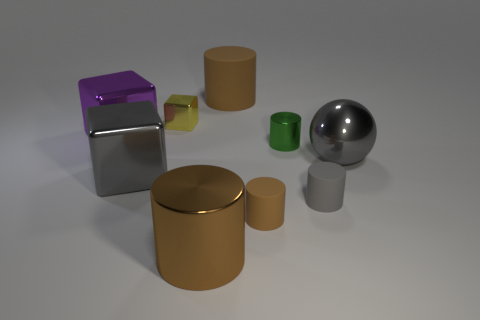The large rubber cylinder has what color?
Provide a short and direct response. Brown. There is a big gray object that is right of the tiny gray matte cylinder; is there a purple object that is to the left of it?
Your answer should be very brief. Yes. What material is the gray cube?
Make the answer very short. Metal. Is the big brown object that is behind the large gray metallic ball made of the same material as the small yellow thing behind the sphere?
Offer a very short reply. No. Is there anything else that is the same color as the small block?
Ensure brevity in your answer.  No. There is another shiny object that is the same shape as the large brown metallic object; what color is it?
Offer a very short reply. Green. What is the size of the matte cylinder that is on the left side of the green shiny cylinder and in front of the purple block?
Make the answer very short. Small. Do the big brown thing that is behind the yellow thing and the tiny shiny thing on the right side of the tiny metal block have the same shape?
Make the answer very short. Yes. The large object that is the same color as the big shiny ball is what shape?
Give a very brief answer. Cube. How many yellow blocks are the same material as the large gray block?
Your response must be concise. 1. 